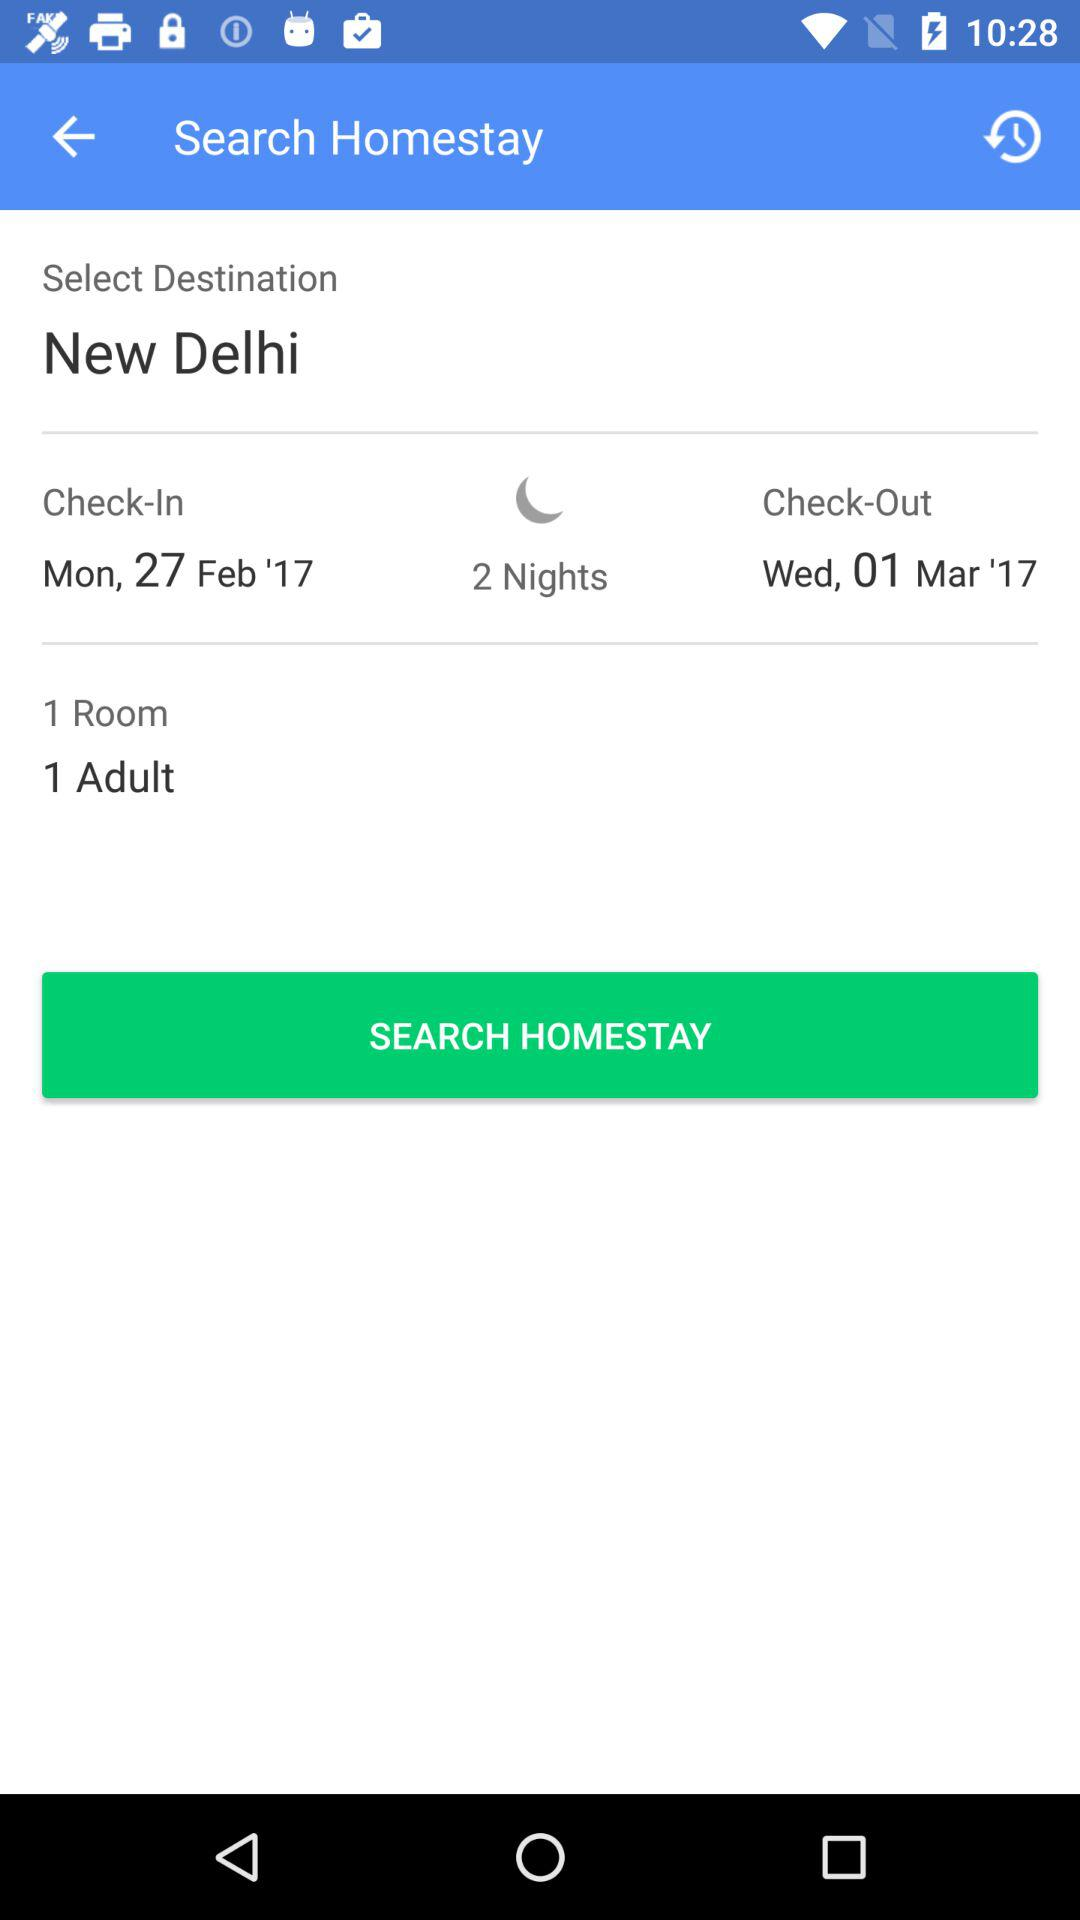What is the number of rooms? The number of rooms is 1. 